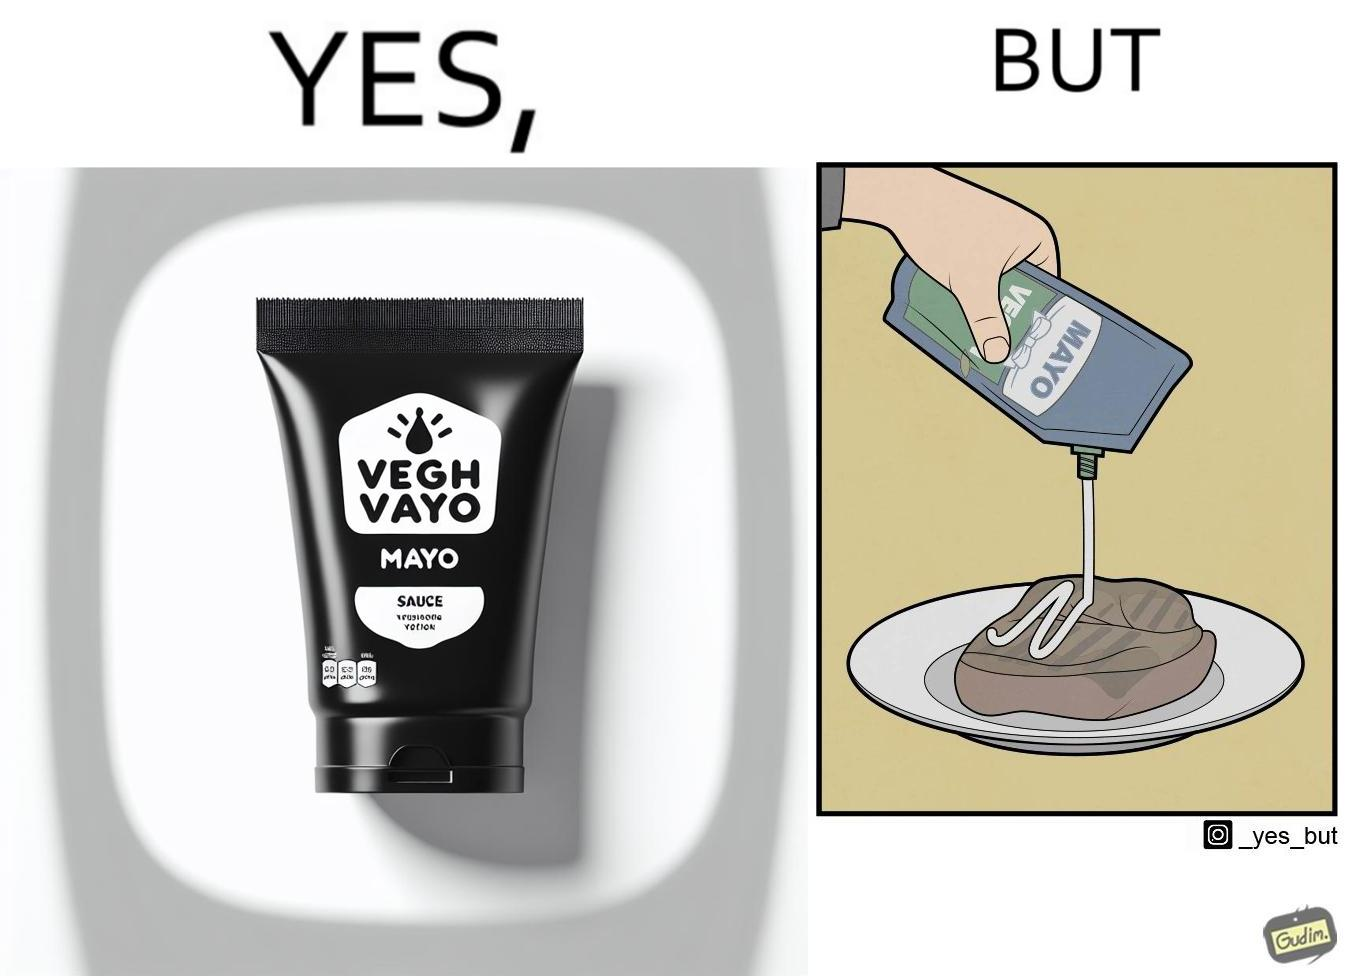Provide a description of this image. The image is ironical, as vegan mayo sauce is being poured on rib steak, which is non-vegetarian. The person might as well just use normal mayo sauce instead. 